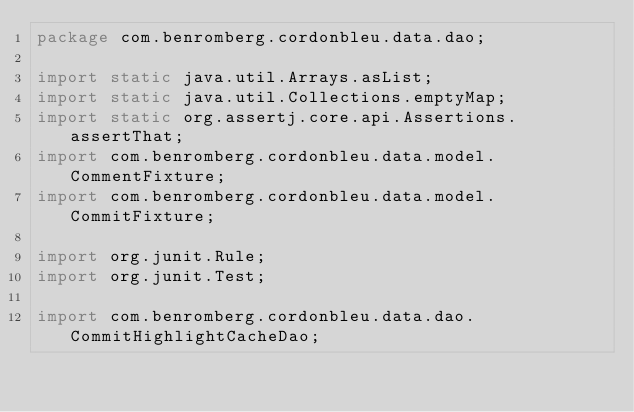<code> <loc_0><loc_0><loc_500><loc_500><_Java_>package com.benromberg.cordonbleu.data.dao;

import static java.util.Arrays.asList;
import static java.util.Collections.emptyMap;
import static org.assertj.core.api.Assertions.assertThat;
import com.benromberg.cordonbleu.data.model.CommentFixture;
import com.benromberg.cordonbleu.data.model.CommitFixture;

import org.junit.Rule;
import org.junit.Test;

import com.benromberg.cordonbleu.data.dao.CommitHighlightCacheDao;</code> 